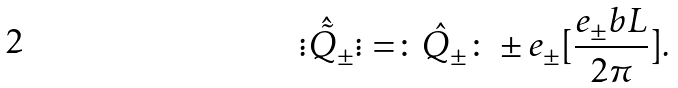Convert formula to latex. <formula><loc_0><loc_0><loc_500><loc_500>\vdots \hat { \tilde { Q } } _ { \pm } \vdots = \colon \hat { Q } _ { \pm } \colon \pm e _ { \pm } [ \frac { e _ { \pm } b L } { 2 { \pi } { } } ] .</formula> 